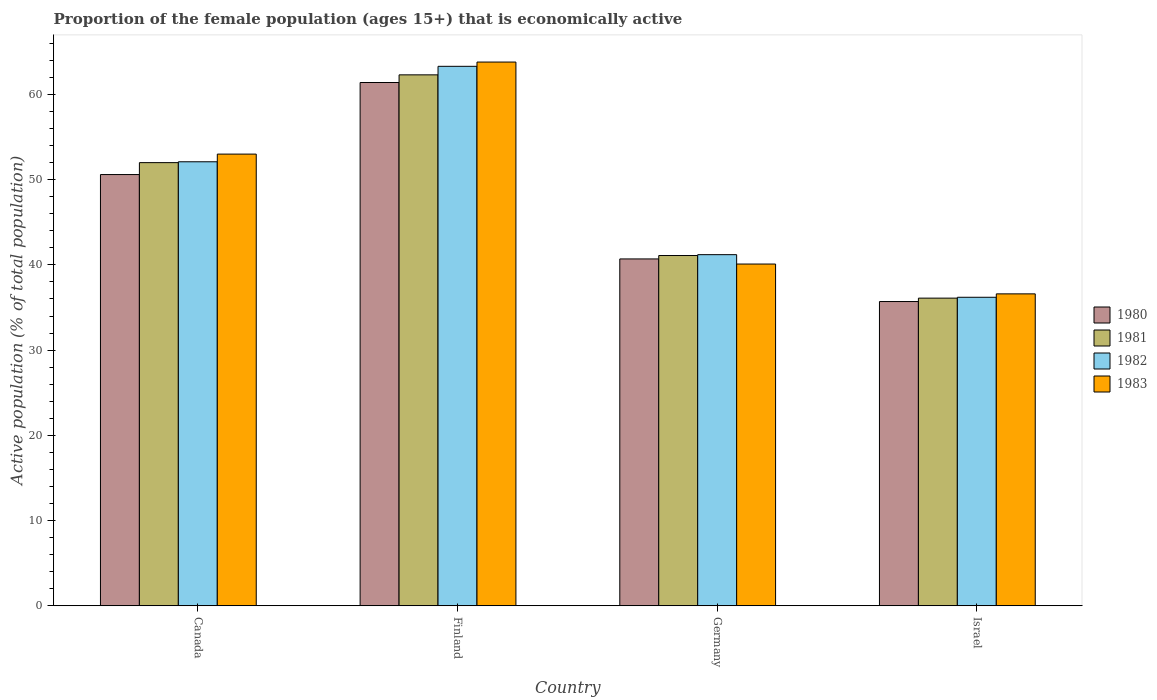How many different coloured bars are there?
Provide a short and direct response. 4. Are the number of bars per tick equal to the number of legend labels?
Your answer should be very brief. Yes. What is the proportion of the female population that is economically active in 1982 in Israel?
Your answer should be compact. 36.2. Across all countries, what is the maximum proportion of the female population that is economically active in 1983?
Your answer should be very brief. 63.8. Across all countries, what is the minimum proportion of the female population that is economically active in 1980?
Keep it short and to the point. 35.7. In which country was the proportion of the female population that is economically active in 1983 maximum?
Make the answer very short. Finland. What is the total proportion of the female population that is economically active in 1982 in the graph?
Your response must be concise. 192.8. What is the difference between the proportion of the female population that is economically active in 1982 in Canada and that in Israel?
Ensure brevity in your answer.  15.9. What is the difference between the proportion of the female population that is economically active in 1981 in Canada and the proportion of the female population that is economically active in 1983 in Finland?
Ensure brevity in your answer.  -11.8. What is the average proportion of the female population that is economically active in 1983 per country?
Provide a short and direct response. 48.37. What is the difference between the proportion of the female population that is economically active of/in 1981 and proportion of the female population that is economically active of/in 1980 in Canada?
Give a very brief answer. 1.4. In how many countries, is the proportion of the female population that is economically active in 1980 greater than 34 %?
Give a very brief answer. 4. What is the ratio of the proportion of the female population that is economically active in 1981 in Finland to that in Germany?
Provide a short and direct response. 1.52. Is the proportion of the female population that is economically active in 1983 in Finland less than that in Germany?
Offer a very short reply. No. What is the difference between the highest and the second highest proportion of the female population that is economically active in 1980?
Your answer should be very brief. -9.9. What is the difference between the highest and the lowest proportion of the female population that is economically active in 1981?
Ensure brevity in your answer.  26.2. Is the sum of the proportion of the female population that is economically active in 1980 in Finland and Germany greater than the maximum proportion of the female population that is economically active in 1982 across all countries?
Your response must be concise. Yes. Is it the case that in every country, the sum of the proportion of the female population that is economically active in 1982 and proportion of the female population that is economically active in 1981 is greater than the sum of proportion of the female population that is economically active in 1980 and proportion of the female population that is economically active in 1983?
Make the answer very short. No. What does the 1st bar from the left in Germany represents?
Offer a terse response. 1980. What does the 1st bar from the right in Canada represents?
Offer a terse response. 1983. Is it the case that in every country, the sum of the proportion of the female population that is economically active in 1980 and proportion of the female population that is economically active in 1983 is greater than the proportion of the female population that is economically active in 1982?
Provide a short and direct response. Yes. How many bars are there?
Give a very brief answer. 16. Are all the bars in the graph horizontal?
Your answer should be very brief. No. How many countries are there in the graph?
Your response must be concise. 4. What is the difference between two consecutive major ticks on the Y-axis?
Your answer should be very brief. 10. Does the graph contain grids?
Keep it short and to the point. No. Where does the legend appear in the graph?
Provide a short and direct response. Center right. How are the legend labels stacked?
Offer a terse response. Vertical. What is the title of the graph?
Provide a succinct answer. Proportion of the female population (ages 15+) that is economically active. What is the label or title of the X-axis?
Provide a short and direct response. Country. What is the label or title of the Y-axis?
Ensure brevity in your answer.  Active population (% of total population). What is the Active population (% of total population) of 1980 in Canada?
Your answer should be very brief. 50.6. What is the Active population (% of total population) in 1982 in Canada?
Provide a succinct answer. 52.1. What is the Active population (% of total population) of 1980 in Finland?
Your answer should be compact. 61.4. What is the Active population (% of total population) of 1981 in Finland?
Offer a very short reply. 62.3. What is the Active population (% of total population) of 1982 in Finland?
Your response must be concise. 63.3. What is the Active population (% of total population) of 1983 in Finland?
Offer a terse response. 63.8. What is the Active population (% of total population) of 1980 in Germany?
Ensure brevity in your answer.  40.7. What is the Active population (% of total population) in 1981 in Germany?
Make the answer very short. 41.1. What is the Active population (% of total population) in 1982 in Germany?
Keep it short and to the point. 41.2. What is the Active population (% of total population) of 1983 in Germany?
Make the answer very short. 40.1. What is the Active population (% of total population) in 1980 in Israel?
Keep it short and to the point. 35.7. What is the Active population (% of total population) of 1981 in Israel?
Offer a terse response. 36.1. What is the Active population (% of total population) of 1982 in Israel?
Offer a very short reply. 36.2. What is the Active population (% of total population) of 1983 in Israel?
Offer a terse response. 36.6. Across all countries, what is the maximum Active population (% of total population) of 1980?
Ensure brevity in your answer.  61.4. Across all countries, what is the maximum Active population (% of total population) of 1981?
Your answer should be very brief. 62.3. Across all countries, what is the maximum Active population (% of total population) of 1982?
Make the answer very short. 63.3. Across all countries, what is the maximum Active population (% of total population) in 1983?
Provide a succinct answer. 63.8. Across all countries, what is the minimum Active population (% of total population) in 1980?
Keep it short and to the point. 35.7. Across all countries, what is the minimum Active population (% of total population) in 1981?
Your response must be concise. 36.1. Across all countries, what is the minimum Active population (% of total population) in 1982?
Your answer should be compact. 36.2. Across all countries, what is the minimum Active population (% of total population) of 1983?
Keep it short and to the point. 36.6. What is the total Active population (% of total population) in 1980 in the graph?
Offer a terse response. 188.4. What is the total Active population (% of total population) of 1981 in the graph?
Provide a succinct answer. 191.5. What is the total Active population (% of total population) in 1982 in the graph?
Offer a very short reply. 192.8. What is the total Active population (% of total population) in 1983 in the graph?
Keep it short and to the point. 193.5. What is the difference between the Active population (% of total population) of 1980 in Canada and that in Finland?
Provide a short and direct response. -10.8. What is the difference between the Active population (% of total population) in 1982 in Canada and that in Finland?
Your answer should be compact. -11.2. What is the difference between the Active population (% of total population) of 1980 in Finland and that in Germany?
Offer a terse response. 20.7. What is the difference between the Active population (% of total population) in 1981 in Finland and that in Germany?
Provide a short and direct response. 21.2. What is the difference between the Active population (% of total population) in 1982 in Finland and that in Germany?
Offer a terse response. 22.1. What is the difference between the Active population (% of total population) in 1983 in Finland and that in Germany?
Provide a succinct answer. 23.7. What is the difference between the Active population (% of total population) of 1980 in Finland and that in Israel?
Offer a very short reply. 25.7. What is the difference between the Active population (% of total population) of 1981 in Finland and that in Israel?
Keep it short and to the point. 26.2. What is the difference between the Active population (% of total population) of 1982 in Finland and that in Israel?
Give a very brief answer. 27.1. What is the difference between the Active population (% of total population) in 1983 in Finland and that in Israel?
Your response must be concise. 27.2. What is the difference between the Active population (% of total population) of 1980 in Germany and that in Israel?
Keep it short and to the point. 5. What is the difference between the Active population (% of total population) in 1981 in Germany and that in Israel?
Keep it short and to the point. 5. What is the difference between the Active population (% of total population) in 1983 in Germany and that in Israel?
Your answer should be compact. 3.5. What is the difference between the Active population (% of total population) of 1980 in Canada and the Active population (% of total population) of 1981 in Finland?
Make the answer very short. -11.7. What is the difference between the Active population (% of total population) in 1980 in Canada and the Active population (% of total population) in 1981 in Germany?
Your answer should be compact. 9.5. What is the difference between the Active population (% of total population) of 1980 in Canada and the Active population (% of total population) of 1982 in Germany?
Offer a very short reply. 9.4. What is the difference between the Active population (% of total population) of 1981 in Canada and the Active population (% of total population) of 1982 in Germany?
Provide a short and direct response. 10.8. What is the difference between the Active population (% of total population) of 1981 in Canada and the Active population (% of total population) of 1983 in Germany?
Your response must be concise. 11.9. What is the difference between the Active population (% of total population) in 1982 in Canada and the Active population (% of total population) in 1983 in Germany?
Your answer should be compact. 12. What is the difference between the Active population (% of total population) in 1980 in Canada and the Active population (% of total population) in 1982 in Israel?
Provide a succinct answer. 14.4. What is the difference between the Active population (% of total population) of 1981 in Canada and the Active population (% of total population) of 1982 in Israel?
Offer a very short reply. 15.8. What is the difference between the Active population (% of total population) in 1981 in Canada and the Active population (% of total population) in 1983 in Israel?
Provide a succinct answer. 15.4. What is the difference between the Active population (% of total population) in 1980 in Finland and the Active population (% of total population) in 1981 in Germany?
Offer a very short reply. 20.3. What is the difference between the Active population (% of total population) in 1980 in Finland and the Active population (% of total population) in 1982 in Germany?
Make the answer very short. 20.2. What is the difference between the Active population (% of total population) of 1980 in Finland and the Active population (% of total population) of 1983 in Germany?
Provide a short and direct response. 21.3. What is the difference between the Active population (% of total population) in 1981 in Finland and the Active population (% of total population) in 1982 in Germany?
Offer a terse response. 21.1. What is the difference between the Active population (% of total population) in 1982 in Finland and the Active population (% of total population) in 1983 in Germany?
Your answer should be compact. 23.2. What is the difference between the Active population (% of total population) in 1980 in Finland and the Active population (% of total population) in 1981 in Israel?
Your answer should be very brief. 25.3. What is the difference between the Active population (% of total population) in 1980 in Finland and the Active population (% of total population) in 1982 in Israel?
Offer a terse response. 25.2. What is the difference between the Active population (% of total population) in 1980 in Finland and the Active population (% of total population) in 1983 in Israel?
Offer a very short reply. 24.8. What is the difference between the Active population (% of total population) of 1981 in Finland and the Active population (% of total population) of 1982 in Israel?
Give a very brief answer. 26.1. What is the difference between the Active population (% of total population) of 1981 in Finland and the Active population (% of total population) of 1983 in Israel?
Give a very brief answer. 25.7. What is the difference between the Active population (% of total population) in 1982 in Finland and the Active population (% of total population) in 1983 in Israel?
Give a very brief answer. 26.7. What is the difference between the Active population (% of total population) of 1980 in Germany and the Active population (% of total population) of 1982 in Israel?
Offer a very short reply. 4.5. What is the average Active population (% of total population) of 1980 per country?
Keep it short and to the point. 47.1. What is the average Active population (% of total population) in 1981 per country?
Offer a terse response. 47.88. What is the average Active population (% of total population) in 1982 per country?
Provide a succinct answer. 48.2. What is the average Active population (% of total population) in 1983 per country?
Keep it short and to the point. 48.38. What is the difference between the Active population (% of total population) of 1980 and Active population (% of total population) of 1983 in Canada?
Provide a short and direct response. -2.4. What is the difference between the Active population (% of total population) in 1981 and Active population (% of total population) in 1983 in Canada?
Provide a succinct answer. -1. What is the difference between the Active population (% of total population) of 1980 and Active population (% of total population) of 1983 in Finland?
Your answer should be compact. -2.4. What is the difference between the Active population (% of total population) in 1981 and Active population (% of total population) in 1983 in Finland?
Ensure brevity in your answer.  -1.5. What is the difference between the Active population (% of total population) in 1982 and Active population (% of total population) in 1983 in Finland?
Make the answer very short. -0.5. What is the difference between the Active population (% of total population) in 1980 and Active population (% of total population) in 1981 in Germany?
Your answer should be very brief. -0.4. What is the difference between the Active population (% of total population) of 1980 and Active population (% of total population) of 1982 in Germany?
Your response must be concise. -0.5. What is the difference between the Active population (% of total population) in 1980 and Active population (% of total population) in 1983 in Germany?
Your answer should be very brief. 0.6. What is the difference between the Active population (% of total population) in 1981 and Active population (% of total population) in 1983 in Germany?
Offer a very short reply. 1. What is the difference between the Active population (% of total population) in 1982 and Active population (% of total population) in 1983 in Germany?
Offer a very short reply. 1.1. What is the difference between the Active population (% of total population) in 1980 and Active population (% of total population) in 1981 in Israel?
Your answer should be very brief. -0.4. What is the difference between the Active population (% of total population) of 1981 and Active population (% of total population) of 1983 in Israel?
Make the answer very short. -0.5. What is the difference between the Active population (% of total population) in 1982 and Active population (% of total population) in 1983 in Israel?
Give a very brief answer. -0.4. What is the ratio of the Active population (% of total population) in 1980 in Canada to that in Finland?
Your answer should be compact. 0.82. What is the ratio of the Active population (% of total population) of 1981 in Canada to that in Finland?
Ensure brevity in your answer.  0.83. What is the ratio of the Active population (% of total population) of 1982 in Canada to that in Finland?
Your answer should be compact. 0.82. What is the ratio of the Active population (% of total population) in 1983 in Canada to that in Finland?
Give a very brief answer. 0.83. What is the ratio of the Active population (% of total population) in 1980 in Canada to that in Germany?
Give a very brief answer. 1.24. What is the ratio of the Active population (% of total population) in 1981 in Canada to that in Germany?
Ensure brevity in your answer.  1.27. What is the ratio of the Active population (% of total population) of 1982 in Canada to that in Germany?
Your answer should be very brief. 1.26. What is the ratio of the Active population (% of total population) of 1983 in Canada to that in Germany?
Your answer should be very brief. 1.32. What is the ratio of the Active population (% of total population) of 1980 in Canada to that in Israel?
Provide a succinct answer. 1.42. What is the ratio of the Active population (% of total population) in 1981 in Canada to that in Israel?
Give a very brief answer. 1.44. What is the ratio of the Active population (% of total population) in 1982 in Canada to that in Israel?
Keep it short and to the point. 1.44. What is the ratio of the Active population (% of total population) in 1983 in Canada to that in Israel?
Your response must be concise. 1.45. What is the ratio of the Active population (% of total population) in 1980 in Finland to that in Germany?
Provide a succinct answer. 1.51. What is the ratio of the Active population (% of total population) of 1981 in Finland to that in Germany?
Offer a very short reply. 1.52. What is the ratio of the Active population (% of total population) of 1982 in Finland to that in Germany?
Keep it short and to the point. 1.54. What is the ratio of the Active population (% of total population) of 1983 in Finland to that in Germany?
Provide a short and direct response. 1.59. What is the ratio of the Active population (% of total population) in 1980 in Finland to that in Israel?
Provide a succinct answer. 1.72. What is the ratio of the Active population (% of total population) of 1981 in Finland to that in Israel?
Your answer should be very brief. 1.73. What is the ratio of the Active population (% of total population) in 1982 in Finland to that in Israel?
Your response must be concise. 1.75. What is the ratio of the Active population (% of total population) in 1983 in Finland to that in Israel?
Your answer should be very brief. 1.74. What is the ratio of the Active population (% of total population) of 1980 in Germany to that in Israel?
Offer a very short reply. 1.14. What is the ratio of the Active population (% of total population) in 1981 in Germany to that in Israel?
Your answer should be compact. 1.14. What is the ratio of the Active population (% of total population) in 1982 in Germany to that in Israel?
Ensure brevity in your answer.  1.14. What is the ratio of the Active population (% of total population) in 1983 in Germany to that in Israel?
Offer a very short reply. 1.1. What is the difference between the highest and the second highest Active population (% of total population) in 1980?
Offer a very short reply. 10.8. What is the difference between the highest and the lowest Active population (% of total population) in 1980?
Your response must be concise. 25.7. What is the difference between the highest and the lowest Active population (% of total population) in 1981?
Keep it short and to the point. 26.2. What is the difference between the highest and the lowest Active population (% of total population) in 1982?
Offer a terse response. 27.1. What is the difference between the highest and the lowest Active population (% of total population) in 1983?
Offer a very short reply. 27.2. 